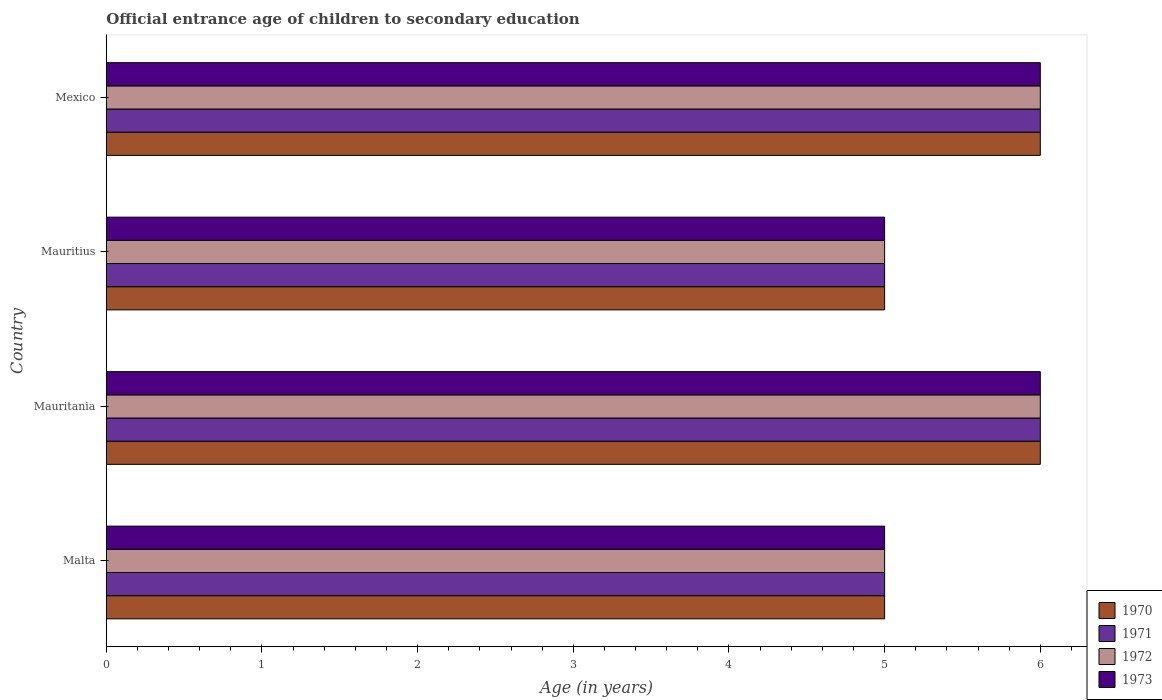How many groups of bars are there?
Give a very brief answer. 4. Are the number of bars per tick equal to the number of legend labels?
Provide a short and direct response. Yes. How many bars are there on the 4th tick from the top?
Your answer should be very brief. 4. How many bars are there on the 4th tick from the bottom?
Keep it short and to the point. 4. What is the label of the 4th group of bars from the top?
Offer a terse response. Malta. In how many cases, is the number of bars for a given country not equal to the number of legend labels?
Provide a succinct answer. 0. What is the secondary school starting age of children in 1973 in Mauritania?
Offer a very short reply. 6. Across all countries, what is the minimum secondary school starting age of children in 1971?
Keep it short and to the point. 5. In which country was the secondary school starting age of children in 1970 maximum?
Offer a very short reply. Mauritania. In which country was the secondary school starting age of children in 1973 minimum?
Offer a terse response. Malta. What is the difference between the secondary school starting age of children in 1971 in Mauritania and that in Mauritius?
Ensure brevity in your answer.  1. What is the difference between the secondary school starting age of children in 1971 in Mauritania and the secondary school starting age of children in 1972 in Mexico?
Keep it short and to the point. 0. What is the average secondary school starting age of children in 1971 per country?
Your response must be concise. 5.5. What is the difference between the secondary school starting age of children in 1973 and secondary school starting age of children in 1970 in Mauritius?
Your response must be concise. 0. What is the ratio of the secondary school starting age of children in 1973 in Malta to that in Mauritania?
Offer a very short reply. 0.83. Is the secondary school starting age of children in 1973 in Mauritania less than that in Mexico?
Make the answer very short. No. In how many countries, is the secondary school starting age of children in 1973 greater than the average secondary school starting age of children in 1973 taken over all countries?
Provide a short and direct response. 2. Is the sum of the secondary school starting age of children in 1973 in Mauritania and Mauritius greater than the maximum secondary school starting age of children in 1972 across all countries?
Offer a very short reply. Yes. How many bars are there?
Provide a short and direct response. 16. How many countries are there in the graph?
Ensure brevity in your answer.  4. What is the difference between two consecutive major ticks on the X-axis?
Offer a terse response. 1. Where does the legend appear in the graph?
Keep it short and to the point. Bottom right. How many legend labels are there?
Provide a short and direct response. 4. How are the legend labels stacked?
Keep it short and to the point. Vertical. What is the title of the graph?
Give a very brief answer. Official entrance age of children to secondary education. What is the label or title of the X-axis?
Your answer should be compact. Age (in years). What is the Age (in years) in 1971 in Malta?
Your answer should be very brief. 5. What is the Age (in years) in 1973 in Mauritania?
Ensure brevity in your answer.  6. What is the Age (in years) of 1971 in Mauritius?
Provide a succinct answer. 5. What is the Age (in years) of 1973 in Mauritius?
Ensure brevity in your answer.  5. What is the Age (in years) of 1970 in Mexico?
Provide a succinct answer. 6. What is the Age (in years) of 1971 in Mexico?
Your response must be concise. 6. What is the Age (in years) in 1972 in Mexico?
Your answer should be compact. 6. Across all countries, what is the maximum Age (in years) in 1970?
Give a very brief answer. 6. Across all countries, what is the maximum Age (in years) in 1971?
Ensure brevity in your answer.  6. Across all countries, what is the maximum Age (in years) in 1972?
Provide a succinct answer. 6. Across all countries, what is the maximum Age (in years) of 1973?
Your answer should be compact. 6. Across all countries, what is the minimum Age (in years) of 1972?
Your answer should be compact. 5. What is the total Age (in years) of 1971 in the graph?
Offer a very short reply. 22. What is the total Age (in years) of 1972 in the graph?
Your answer should be very brief. 22. What is the total Age (in years) of 1973 in the graph?
Provide a short and direct response. 22. What is the difference between the Age (in years) in 1971 in Malta and that in Mauritania?
Your answer should be compact. -1. What is the difference between the Age (in years) in 1973 in Malta and that in Mauritania?
Provide a short and direct response. -1. What is the difference between the Age (in years) of 1970 in Malta and that in Mauritius?
Make the answer very short. 0. What is the difference between the Age (in years) of 1971 in Malta and that in Mauritius?
Keep it short and to the point. 0. What is the difference between the Age (in years) in 1973 in Malta and that in Mauritius?
Provide a short and direct response. 0. What is the difference between the Age (in years) in 1972 in Malta and that in Mexico?
Your response must be concise. -1. What is the difference between the Age (in years) of 1970 in Mauritania and that in Mauritius?
Ensure brevity in your answer.  1. What is the difference between the Age (in years) in 1971 in Mauritania and that in Mauritius?
Offer a terse response. 1. What is the difference between the Age (in years) in 1972 in Mauritania and that in Mauritius?
Keep it short and to the point. 1. What is the difference between the Age (in years) of 1970 in Mauritania and that in Mexico?
Give a very brief answer. 0. What is the difference between the Age (in years) of 1972 in Mauritania and that in Mexico?
Keep it short and to the point. 0. What is the difference between the Age (in years) in 1972 in Mauritius and that in Mexico?
Provide a succinct answer. -1. What is the difference between the Age (in years) in 1970 in Malta and the Age (in years) in 1972 in Mauritania?
Ensure brevity in your answer.  -1. What is the difference between the Age (in years) in 1970 in Malta and the Age (in years) in 1973 in Mauritania?
Give a very brief answer. -1. What is the difference between the Age (in years) of 1971 in Malta and the Age (in years) of 1973 in Mauritania?
Ensure brevity in your answer.  -1. What is the difference between the Age (in years) in 1972 in Malta and the Age (in years) in 1973 in Mauritania?
Offer a very short reply. -1. What is the difference between the Age (in years) of 1970 in Malta and the Age (in years) of 1971 in Mauritius?
Provide a succinct answer. 0. What is the difference between the Age (in years) in 1970 in Malta and the Age (in years) in 1973 in Mauritius?
Your answer should be very brief. 0. What is the difference between the Age (in years) of 1971 in Malta and the Age (in years) of 1972 in Mauritius?
Your response must be concise. 0. What is the difference between the Age (in years) of 1972 in Malta and the Age (in years) of 1973 in Mauritius?
Offer a very short reply. 0. What is the difference between the Age (in years) in 1970 in Malta and the Age (in years) in 1973 in Mexico?
Provide a succinct answer. -1. What is the difference between the Age (in years) of 1971 in Malta and the Age (in years) of 1972 in Mexico?
Your answer should be very brief. -1. What is the difference between the Age (in years) in 1971 in Malta and the Age (in years) in 1973 in Mexico?
Your answer should be very brief. -1. What is the difference between the Age (in years) of 1970 in Mauritania and the Age (in years) of 1972 in Mauritius?
Give a very brief answer. 1. What is the difference between the Age (in years) of 1972 in Mauritania and the Age (in years) of 1973 in Mauritius?
Keep it short and to the point. 1. What is the difference between the Age (in years) in 1970 in Mauritania and the Age (in years) in 1971 in Mexico?
Make the answer very short. 0. What is the difference between the Age (in years) in 1970 in Mauritania and the Age (in years) in 1972 in Mexico?
Give a very brief answer. 0. What is the difference between the Age (in years) in 1970 in Mauritania and the Age (in years) in 1973 in Mexico?
Make the answer very short. 0. What is the difference between the Age (in years) of 1970 in Mauritius and the Age (in years) of 1971 in Mexico?
Your answer should be compact. -1. What is the difference between the Age (in years) of 1970 in Mauritius and the Age (in years) of 1973 in Mexico?
Provide a succinct answer. -1. What is the difference between the Age (in years) in 1971 in Mauritius and the Age (in years) in 1973 in Mexico?
Offer a terse response. -1. What is the average Age (in years) in 1971 per country?
Keep it short and to the point. 5.5. What is the average Age (in years) of 1972 per country?
Give a very brief answer. 5.5. What is the difference between the Age (in years) of 1972 and Age (in years) of 1973 in Malta?
Offer a very short reply. 0. What is the difference between the Age (in years) in 1970 and Age (in years) in 1971 in Mauritania?
Offer a very short reply. 0. What is the difference between the Age (in years) of 1970 and Age (in years) of 1973 in Mauritania?
Ensure brevity in your answer.  0. What is the difference between the Age (in years) of 1972 and Age (in years) of 1973 in Mauritania?
Your answer should be compact. 0. What is the difference between the Age (in years) of 1970 and Age (in years) of 1971 in Mauritius?
Offer a terse response. 0. What is the difference between the Age (in years) of 1971 and Age (in years) of 1973 in Mauritius?
Make the answer very short. 0. What is the difference between the Age (in years) in 1970 and Age (in years) in 1971 in Mexico?
Your response must be concise. 0. What is the difference between the Age (in years) of 1970 and Age (in years) of 1972 in Mexico?
Ensure brevity in your answer.  0. What is the difference between the Age (in years) of 1970 and Age (in years) of 1973 in Mexico?
Offer a very short reply. 0. What is the difference between the Age (in years) in 1971 and Age (in years) in 1972 in Mexico?
Provide a succinct answer. 0. What is the difference between the Age (in years) in 1971 and Age (in years) in 1973 in Mexico?
Ensure brevity in your answer.  0. What is the ratio of the Age (in years) in 1970 in Malta to that in Mauritania?
Your answer should be very brief. 0.83. What is the ratio of the Age (in years) in 1972 in Malta to that in Mauritania?
Offer a terse response. 0.83. What is the ratio of the Age (in years) of 1973 in Malta to that in Mauritania?
Ensure brevity in your answer.  0.83. What is the ratio of the Age (in years) in 1971 in Malta to that in Mauritius?
Make the answer very short. 1. What is the ratio of the Age (in years) of 1971 in Malta to that in Mexico?
Your answer should be compact. 0.83. What is the ratio of the Age (in years) of 1973 in Mauritania to that in Mauritius?
Your answer should be very brief. 1.2. What is the ratio of the Age (in years) of 1970 in Mauritania to that in Mexico?
Your response must be concise. 1. What is the ratio of the Age (in years) of 1972 in Mauritania to that in Mexico?
Provide a short and direct response. 1. What is the ratio of the Age (in years) of 1973 in Mauritania to that in Mexico?
Offer a terse response. 1. What is the difference between the highest and the second highest Age (in years) in 1971?
Ensure brevity in your answer.  0. What is the difference between the highest and the second highest Age (in years) in 1972?
Offer a terse response. 0. What is the difference between the highest and the second highest Age (in years) in 1973?
Keep it short and to the point. 0. What is the difference between the highest and the lowest Age (in years) in 1970?
Ensure brevity in your answer.  1. What is the difference between the highest and the lowest Age (in years) in 1971?
Offer a very short reply. 1. 